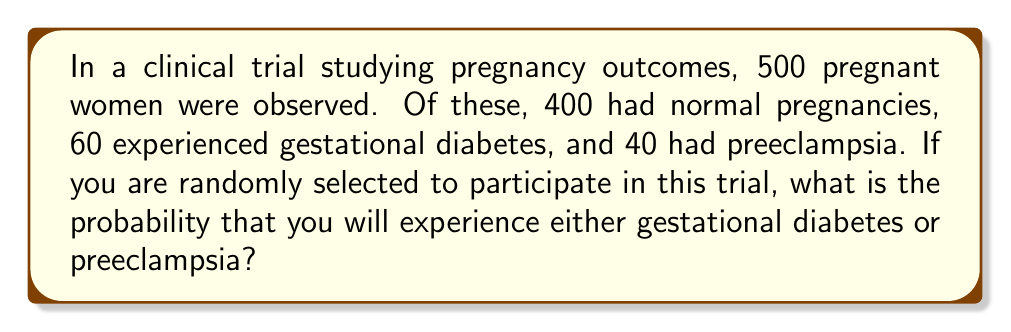Can you answer this question? To solve this problem, we'll use the concept of probability and the addition rule for mutually exclusive events.

1. First, let's define our events:
   A: experiencing gestational diabetes
   B: experiencing preeclampsia

2. We need to calculate P(A or B), which is the probability of experiencing either gestational diabetes or preeclampsia.

3. Since these outcomes are mutually exclusive (a woman cannot have both conditions simultaneously), we can use the addition rule:

   P(A or B) = P(A) + P(B)

4. Calculate P(A) - probability of gestational diabetes:
   P(A) = $\frac{\text{Number of women with gestational diabetes}}{\text{Total number of women}}$ = $\frac{60}{500}$ = $0.12$

5. Calculate P(B) - probability of preeclampsia:
   P(B) = $\frac{\text{Number of women with preeclampsia}}{\text{Total number of women}}$ = $\frac{40}{500}$ = $0.08$

6. Now, we can apply the addition rule:
   P(A or B) = P(A) + P(B) = $0.12 + 0.08$ = $0.20$

Therefore, the probability of experiencing either gestational diabetes or preeclampsia is 0.20 or 20%.
Answer: 0.20 or 20% 